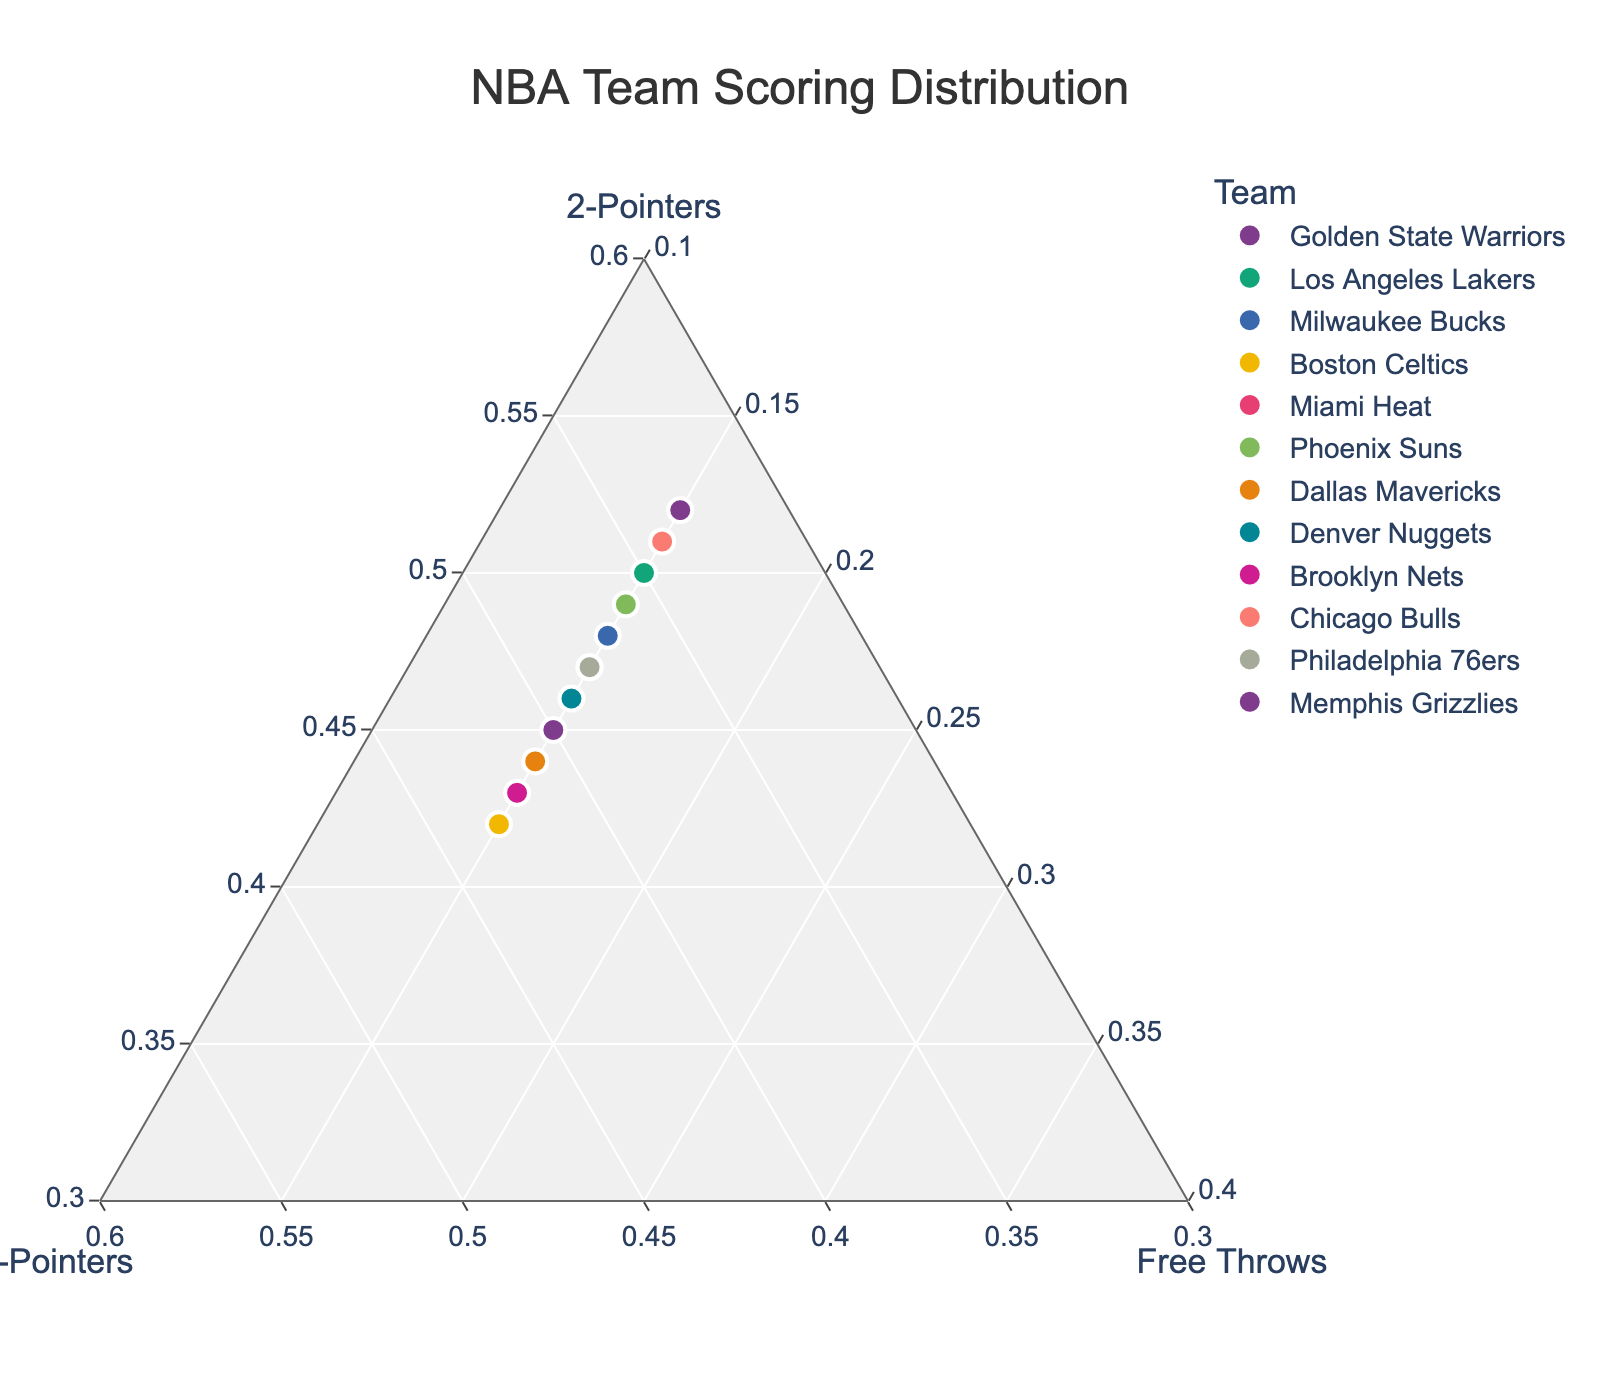How many teams are represented in the plot? Count the number of unique teams labeled in the plot.
Answer: 12 Which axis represents Three-Pointers? The axis labeled '3-Pointers' in the ternary plot represents Three-Pointers.
Answer: The right axis Which team has the highest percentage of points from Three-Pointers? Look for the team positioned closest to the '3-Pointers' axis. This should be the team with the highest percentage from Three-Pointers.
Answer: Boston Celtics What is the percentage of points from 2-Pointers for the Memphis Grizzlies? Hover over the point labeled 'Memphis Grizzlies' and check the percentage of points from 2-Pointers.
Answer: 52% Which team scores the least from Free Throws? All teams have an equal contribution from Free Throws, so every team has the same percentage for Free Throws.
Answer: All teams Compare the Golden State Warriors and the Los Angeles Lakers, which team scores more from Three-Pointers? Find and compare the positions of Golden State Warriors and Los Angeles Lakers along the '3-Pointers' axis. Golden State Warriors are closer to the '3-Pointers' axis compared to Los Angeles Lakers.
Answer: Golden State Warriors What is the median percentage of points from 2-Pointers across all teams? List out the percentage of points from 2-Pointers for all teams: 45%, 50%, 48%, 42%, 47%, 49%, 44%, 46%, 43%, 51%, 47%, 52%. Sort them and find the median (46%, 47%, 47%, 48%, 49%, 50%, 51%, 52%). The median value is the average of the 6th and 7th values (48 and 49). (48 + 49)/2 = 48.5%.
Answer: 48.5% Which teams are most similar based on their scoring distribution? Look for clusters where teams are positioned closely together. For instance, Phoenix Suns and Los Angeles Lakers are close to one another.
Answer: Phoenix Suns and Los Angeles Lakers 